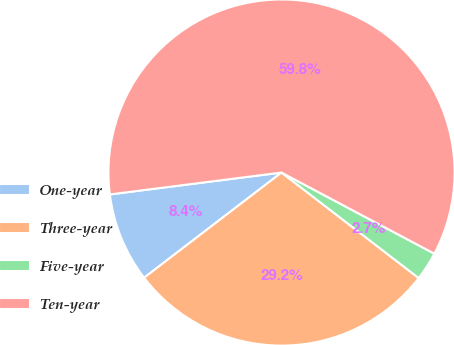Convert chart. <chart><loc_0><loc_0><loc_500><loc_500><pie_chart><fcel>One-year<fcel>Three-year<fcel>Five-year<fcel>Ten-year<nl><fcel>8.38%<fcel>29.16%<fcel>2.67%<fcel>59.78%<nl></chart> 